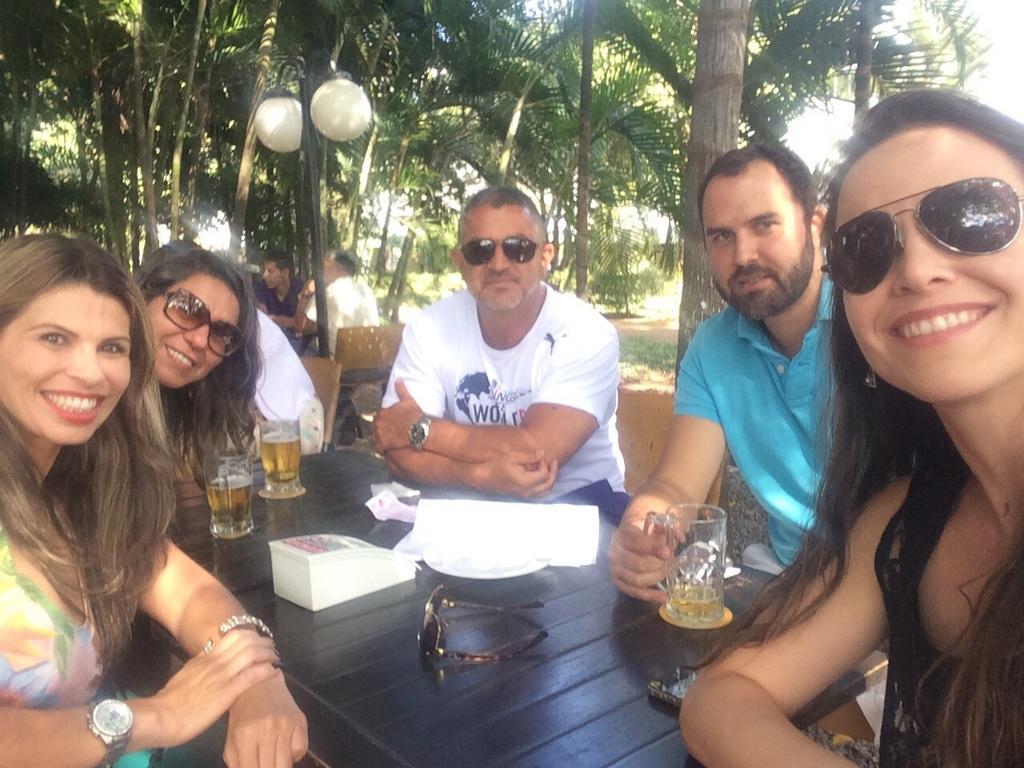Could you give a brief overview of what you see in this image? In this image I can see people sitting on chairs in front of tables. On the table I can see glasses, shades and other objects. This man is holding a glass in the hand. Some of them are smiling. In the background I can see people, pole lights, trees and other objects. 